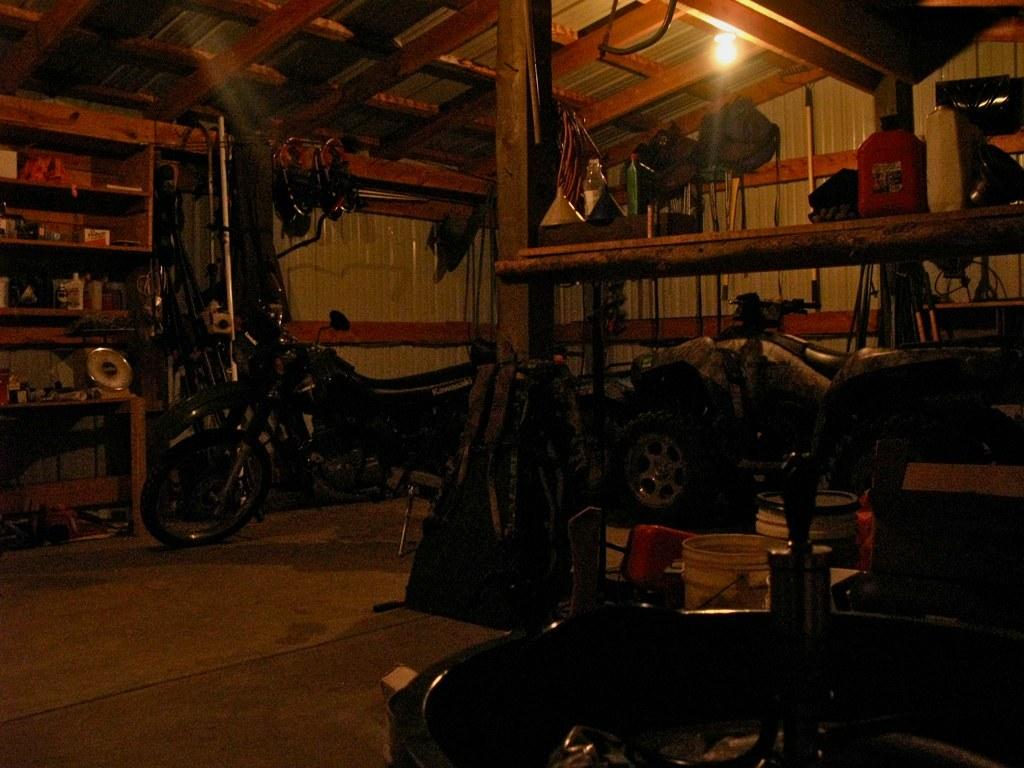What material is the room made of? The room is made of wood. What can be found on the shelf in the room? There is a shelf with objects in the room. What type of vehicle is in the room? There is a bike in the room. Where is the light located in the room? There is a light on the roof of the room. What type of baseball equipment can be seen on the stage in the image? There is no baseball equipment or stage present in the image. 